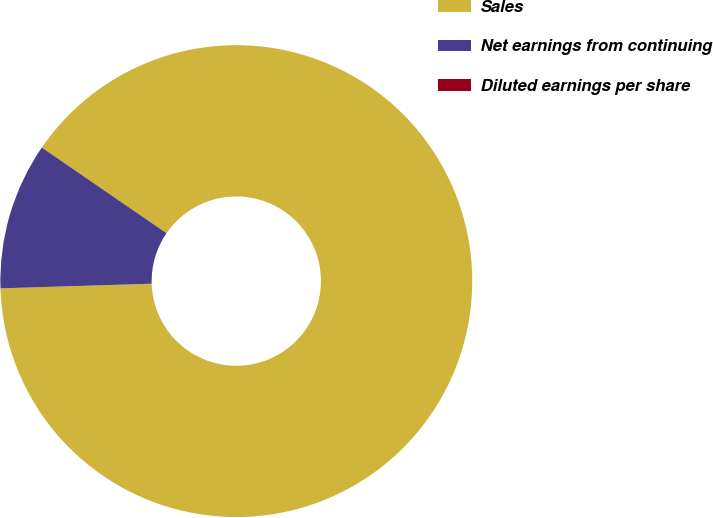Convert chart to OTSL. <chart><loc_0><loc_0><loc_500><loc_500><pie_chart><fcel>Sales<fcel>Net earnings from continuing<fcel>Diluted earnings per share<nl><fcel>89.93%<fcel>10.06%<fcel>0.01%<nl></chart> 